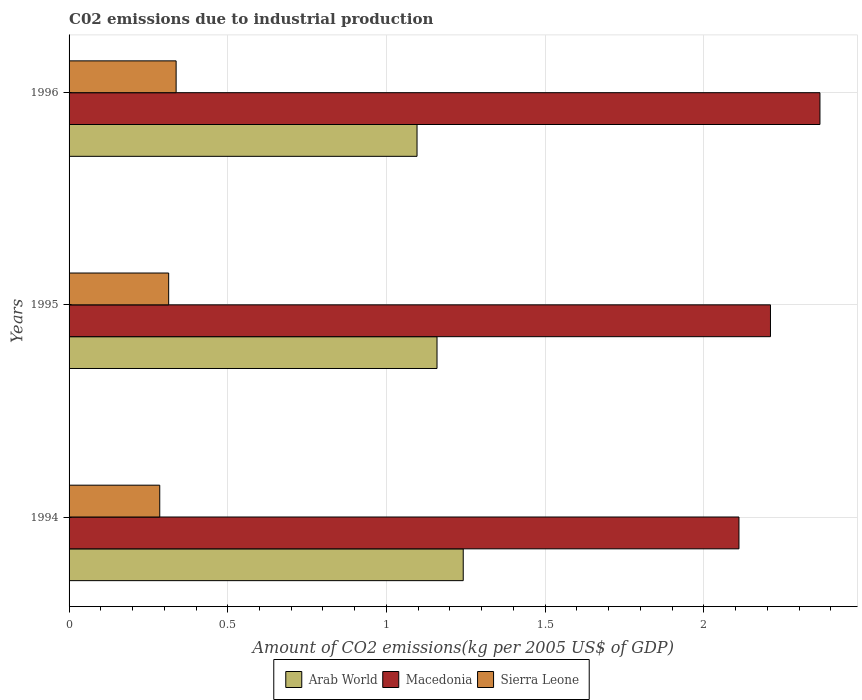How many groups of bars are there?
Offer a terse response. 3. Are the number of bars per tick equal to the number of legend labels?
Offer a very short reply. Yes. How many bars are there on the 2nd tick from the top?
Offer a terse response. 3. How many bars are there on the 3rd tick from the bottom?
Make the answer very short. 3. What is the label of the 1st group of bars from the top?
Offer a very short reply. 1996. In how many cases, is the number of bars for a given year not equal to the number of legend labels?
Give a very brief answer. 0. What is the amount of CO2 emitted due to industrial production in Sierra Leone in 1996?
Keep it short and to the point. 0.34. Across all years, what is the maximum amount of CO2 emitted due to industrial production in Arab World?
Your answer should be very brief. 1.24. Across all years, what is the minimum amount of CO2 emitted due to industrial production in Macedonia?
Give a very brief answer. 2.11. In which year was the amount of CO2 emitted due to industrial production in Sierra Leone maximum?
Offer a terse response. 1996. In which year was the amount of CO2 emitted due to industrial production in Arab World minimum?
Ensure brevity in your answer.  1996. What is the total amount of CO2 emitted due to industrial production in Macedonia in the graph?
Offer a terse response. 6.69. What is the difference between the amount of CO2 emitted due to industrial production in Sierra Leone in 1994 and that in 1996?
Make the answer very short. -0.05. What is the difference between the amount of CO2 emitted due to industrial production in Sierra Leone in 1994 and the amount of CO2 emitted due to industrial production in Arab World in 1995?
Ensure brevity in your answer.  -0.87. What is the average amount of CO2 emitted due to industrial production in Sierra Leone per year?
Make the answer very short. 0.31. In the year 1994, what is the difference between the amount of CO2 emitted due to industrial production in Macedonia and amount of CO2 emitted due to industrial production in Sierra Leone?
Provide a succinct answer. 1.83. In how many years, is the amount of CO2 emitted due to industrial production in Macedonia greater than 1 kg?
Provide a succinct answer. 3. What is the ratio of the amount of CO2 emitted due to industrial production in Arab World in 1994 to that in 1996?
Make the answer very short. 1.13. What is the difference between the highest and the second highest amount of CO2 emitted due to industrial production in Sierra Leone?
Keep it short and to the point. 0.02. What is the difference between the highest and the lowest amount of CO2 emitted due to industrial production in Sierra Leone?
Your answer should be very brief. 0.05. What does the 3rd bar from the top in 1996 represents?
Offer a terse response. Arab World. What does the 1st bar from the bottom in 1995 represents?
Your answer should be compact. Arab World. Is it the case that in every year, the sum of the amount of CO2 emitted due to industrial production in Sierra Leone and amount of CO2 emitted due to industrial production in Macedonia is greater than the amount of CO2 emitted due to industrial production in Arab World?
Ensure brevity in your answer.  Yes. How many bars are there?
Give a very brief answer. 9. Are all the bars in the graph horizontal?
Make the answer very short. Yes. What is the difference between two consecutive major ticks on the X-axis?
Your answer should be compact. 0.5. Are the values on the major ticks of X-axis written in scientific E-notation?
Provide a succinct answer. No. Does the graph contain any zero values?
Give a very brief answer. No. Where does the legend appear in the graph?
Ensure brevity in your answer.  Bottom center. How are the legend labels stacked?
Provide a short and direct response. Horizontal. What is the title of the graph?
Keep it short and to the point. C02 emissions due to industrial production. Does "Timor-Leste" appear as one of the legend labels in the graph?
Provide a short and direct response. No. What is the label or title of the X-axis?
Make the answer very short. Amount of CO2 emissions(kg per 2005 US$ of GDP). What is the Amount of CO2 emissions(kg per 2005 US$ of GDP) of Arab World in 1994?
Give a very brief answer. 1.24. What is the Amount of CO2 emissions(kg per 2005 US$ of GDP) of Macedonia in 1994?
Offer a very short reply. 2.11. What is the Amount of CO2 emissions(kg per 2005 US$ of GDP) of Sierra Leone in 1994?
Ensure brevity in your answer.  0.29. What is the Amount of CO2 emissions(kg per 2005 US$ of GDP) in Arab World in 1995?
Your answer should be very brief. 1.16. What is the Amount of CO2 emissions(kg per 2005 US$ of GDP) of Macedonia in 1995?
Give a very brief answer. 2.21. What is the Amount of CO2 emissions(kg per 2005 US$ of GDP) in Sierra Leone in 1995?
Make the answer very short. 0.31. What is the Amount of CO2 emissions(kg per 2005 US$ of GDP) in Arab World in 1996?
Your response must be concise. 1.1. What is the Amount of CO2 emissions(kg per 2005 US$ of GDP) in Macedonia in 1996?
Your answer should be compact. 2.37. What is the Amount of CO2 emissions(kg per 2005 US$ of GDP) in Sierra Leone in 1996?
Make the answer very short. 0.34. Across all years, what is the maximum Amount of CO2 emissions(kg per 2005 US$ of GDP) of Arab World?
Provide a short and direct response. 1.24. Across all years, what is the maximum Amount of CO2 emissions(kg per 2005 US$ of GDP) of Macedonia?
Give a very brief answer. 2.37. Across all years, what is the maximum Amount of CO2 emissions(kg per 2005 US$ of GDP) of Sierra Leone?
Your answer should be very brief. 0.34. Across all years, what is the minimum Amount of CO2 emissions(kg per 2005 US$ of GDP) of Arab World?
Offer a very short reply. 1.1. Across all years, what is the minimum Amount of CO2 emissions(kg per 2005 US$ of GDP) of Macedonia?
Your answer should be compact. 2.11. Across all years, what is the minimum Amount of CO2 emissions(kg per 2005 US$ of GDP) of Sierra Leone?
Provide a short and direct response. 0.29. What is the total Amount of CO2 emissions(kg per 2005 US$ of GDP) of Arab World in the graph?
Provide a succinct answer. 3.5. What is the total Amount of CO2 emissions(kg per 2005 US$ of GDP) of Macedonia in the graph?
Offer a terse response. 6.69. What is the total Amount of CO2 emissions(kg per 2005 US$ of GDP) of Sierra Leone in the graph?
Provide a succinct answer. 0.94. What is the difference between the Amount of CO2 emissions(kg per 2005 US$ of GDP) in Arab World in 1994 and that in 1995?
Provide a short and direct response. 0.08. What is the difference between the Amount of CO2 emissions(kg per 2005 US$ of GDP) of Macedonia in 1994 and that in 1995?
Provide a succinct answer. -0.1. What is the difference between the Amount of CO2 emissions(kg per 2005 US$ of GDP) in Sierra Leone in 1994 and that in 1995?
Provide a short and direct response. -0.03. What is the difference between the Amount of CO2 emissions(kg per 2005 US$ of GDP) in Arab World in 1994 and that in 1996?
Ensure brevity in your answer.  0.15. What is the difference between the Amount of CO2 emissions(kg per 2005 US$ of GDP) of Macedonia in 1994 and that in 1996?
Provide a short and direct response. -0.26. What is the difference between the Amount of CO2 emissions(kg per 2005 US$ of GDP) of Sierra Leone in 1994 and that in 1996?
Your answer should be compact. -0.05. What is the difference between the Amount of CO2 emissions(kg per 2005 US$ of GDP) in Arab World in 1995 and that in 1996?
Provide a succinct answer. 0.06. What is the difference between the Amount of CO2 emissions(kg per 2005 US$ of GDP) of Macedonia in 1995 and that in 1996?
Your answer should be compact. -0.16. What is the difference between the Amount of CO2 emissions(kg per 2005 US$ of GDP) of Sierra Leone in 1995 and that in 1996?
Your answer should be very brief. -0.02. What is the difference between the Amount of CO2 emissions(kg per 2005 US$ of GDP) in Arab World in 1994 and the Amount of CO2 emissions(kg per 2005 US$ of GDP) in Macedonia in 1995?
Provide a succinct answer. -0.97. What is the difference between the Amount of CO2 emissions(kg per 2005 US$ of GDP) of Arab World in 1994 and the Amount of CO2 emissions(kg per 2005 US$ of GDP) of Sierra Leone in 1995?
Provide a succinct answer. 0.93. What is the difference between the Amount of CO2 emissions(kg per 2005 US$ of GDP) in Macedonia in 1994 and the Amount of CO2 emissions(kg per 2005 US$ of GDP) in Sierra Leone in 1995?
Your answer should be compact. 1.8. What is the difference between the Amount of CO2 emissions(kg per 2005 US$ of GDP) in Arab World in 1994 and the Amount of CO2 emissions(kg per 2005 US$ of GDP) in Macedonia in 1996?
Your response must be concise. -1.12. What is the difference between the Amount of CO2 emissions(kg per 2005 US$ of GDP) of Arab World in 1994 and the Amount of CO2 emissions(kg per 2005 US$ of GDP) of Sierra Leone in 1996?
Give a very brief answer. 0.9. What is the difference between the Amount of CO2 emissions(kg per 2005 US$ of GDP) in Macedonia in 1994 and the Amount of CO2 emissions(kg per 2005 US$ of GDP) in Sierra Leone in 1996?
Your answer should be very brief. 1.77. What is the difference between the Amount of CO2 emissions(kg per 2005 US$ of GDP) of Arab World in 1995 and the Amount of CO2 emissions(kg per 2005 US$ of GDP) of Macedonia in 1996?
Make the answer very short. -1.21. What is the difference between the Amount of CO2 emissions(kg per 2005 US$ of GDP) of Arab World in 1995 and the Amount of CO2 emissions(kg per 2005 US$ of GDP) of Sierra Leone in 1996?
Provide a succinct answer. 0.82. What is the difference between the Amount of CO2 emissions(kg per 2005 US$ of GDP) of Macedonia in 1995 and the Amount of CO2 emissions(kg per 2005 US$ of GDP) of Sierra Leone in 1996?
Your answer should be compact. 1.87. What is the average Amount of CO2 emissions(kg per 2005 US$ of GDP) of Arab World per year?
Provide a short and direct response. 1.17. What is the average Amount of CO2 emissions(kg per 2005 US$ of GDP) of Macedonia per year?
Offer a terse response. 2.23. What is the average Amount of CO2 emissions(kg per 2005 US$ of GDP) of Sierra Leone per year?
Your response must be concise. 0.31. In the year 1994, what is the difference between the Amount of CO2 emissions(kg per 2005 US$ of GDP) in Arab World and Amount of CO2 emissions(kg per 2005 US$ of GDP) in Macedonia?
Your answer should be very brief. -0.87. In the year 1994, what is the difference between the Amount of CO2 emissions(kg per 2005 US$ of GDP) of Arab World and Amount of CO2 emissions(kg per 2005 US$ of GDP) of Sierra Leone?
Offer a terse response. 0.96. In the year 1994, what is the difference between the Amount of CO2 emissions(kg per 2005 US$ of GDP) in Macedonia and Amount of CO2 emissions(kg per 2005 US$ of GDP) in Sierra Leone?
Provide a succinct answer. 1.82. In the year 1995, what is the difference between the Amount of CO2 emissions(kg per 2005 US$ of GDP) of Arab World and Amount of CO2 emissions(kg per 2005 US$ of GDP) of Macedonia?
Give a very brief answer. -1.05. In the year 1995, what is the difference between the Amount of CO2 emissions(kg per 2005 US$ of GDP) of Arab World and Amount of CO2 emissions(kg per 2005 US$ of GDP) of Sierra Leone?
Offer a very short reply. 0.85. In the year 1995, what is the difference between the Amount of CO2 emissions(kg per 2005 US$ of GDP) in Macedonia and Amount of CO2 emissions(kg per 2005 US$ of GDP) in Sierra Leone?
Make the answer very short. 1.9. In the year 1996, what is the difference between the Amount of CO2 emissions(kg per 2005 US$ of GDP) of Arab World and Amount of CO2 emissions(kg per 2005 US$ of GDP) of Macedonia?
Offer a terse response. -1.27. In the year 1996, what is the difference between the Amount of CO2 emissions(kg per 2005 US$ of GDP) in Arab World and Amount of CO2 emissions(kg per 2005 US$ of GDP) in Sierra Leone?
Offer a very short reply. 0.76. In the year 1996, what is the difference between the Amount of CO2 emissions(kg per 2005 US$ of GDP) of Macedonia and Amount of CO2 emissions(kg per 2005 US$ of GDP) of Sierra Leone?
Ensure brevity in your answer.  2.03. What is the ratio of the Amount of CO2 emissions(kg per 2005 US$ of GDP) in Arab World in 1994 to that in 1995?
Your answer should be very brief. 1.07. What is the ratio of the Amount of CO2 emissions(kg per 2005 US$ of GDP) in Macedonia in 1994 to that in 1995?
Make the answer very short. 0.96. What is the ratio of the Amount of CO2 emissions(kg per 2005 US$ of GDP) in Sierra Leone in 1994 to that in 1995?
Make the answer very short. 0.91. What is the ratio of the Amount of CO2 emissions(kg per 2005 US$ of GDP) in Arab World in 1994 to that in 1996?
Make the answer very short. 1.13. What is the ratio of the Amount of CO2 emissions(kg per 2005 US$ of GDP) in Macedonia in 1994 to that in 1996?
Offer a terse response. 0.89. What is the ratio of the Amount of CO2 emissions(kg per 2005 US$ of GDP) of Sierra Leone in 1994 to that in 1996?
Offer a very short reply. 0.85. What is the ratio of the Amount of CO2 emissions(kg per 2005 US$ of GDP) of Arab World in 1995 to that in 1996?
Provide a short and direct response. 1.06. What is the ratio of the Amount of CO2 emissions(kg per 2005 US$ of GDP) in Macedonia in 1995 to that in 1996?
Give a very brief answer. 0.93. What is the ratio of the Amount of CO2 emissions(kg per 2005 US$ of GDP) in Sierra Leone in 1995 to that in 1996?
Your response must be concise. 0.93. What is the difference between the highest and the second highest Amount of CO2 emissions(kg per 2005 US$ of GDP) of Arab World?
Your response must be concise. 0.08. What is the difference between the highest and the second highest Amount of CO2 emissions(kg per 2005 US$ of GDP) of Macedonia?
Your answer should be very brief. 0.16. What is the difference between the highest and the second highest Amount of CO2 emissions(kg per 2005 US$ of GDP) of Sierra Leone?
Make the answer very short. 0.02. What is the difference between the highest and the lowest Amount of CO2 emissions(kg per 2005 US$ of GDP) of Arab World?
Give a very brief answer. 0.15. What is the difference between the highest and the lowest Amount of CO2 emissions(kg per 2005 US$ of GDP) of Macedonia?
Your answer should be compact. 0.26. What is the difference between the highest and the lowest Amount of CO2 emissions(kg per 2005 US$ of GDP) in Sierra Leone?
Offer a terse response. 0.05. 